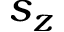Convert formula to latex. <formula><loc_0><loc_0><loc_500><loc_500>s _ { z }</formula> 